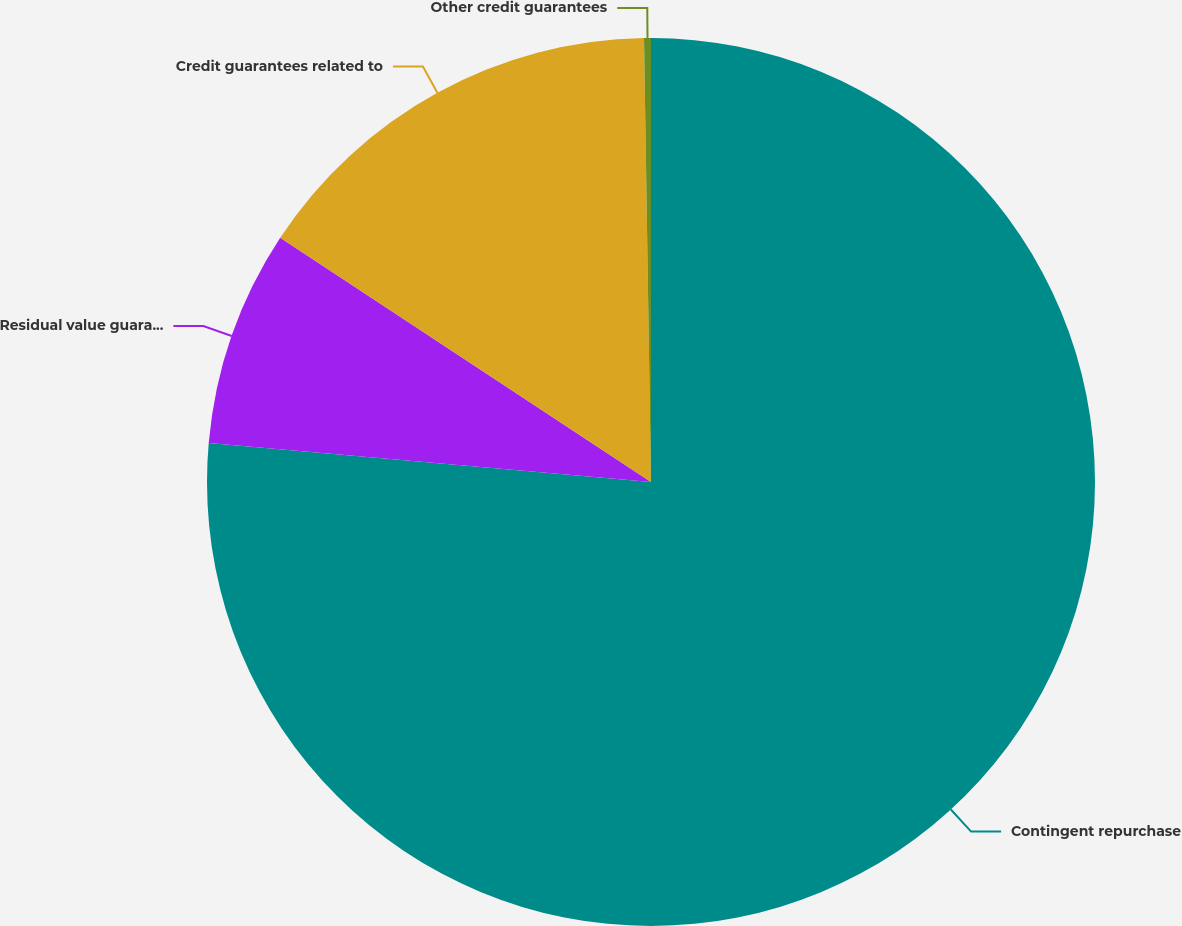Convert chart to OTSL. <chart><loc_0><loc_0><loc_500><loc_500><pie_chart><fcel>Contingent repurchase<fcel>Residual value guarantees<fcel>Credit guarantees related to<fcel>Other credit guarantees<nl><fcel>76.4%<fcel>7.87%<fcel>15.48%<fcel>0.25%<nl></chart> 